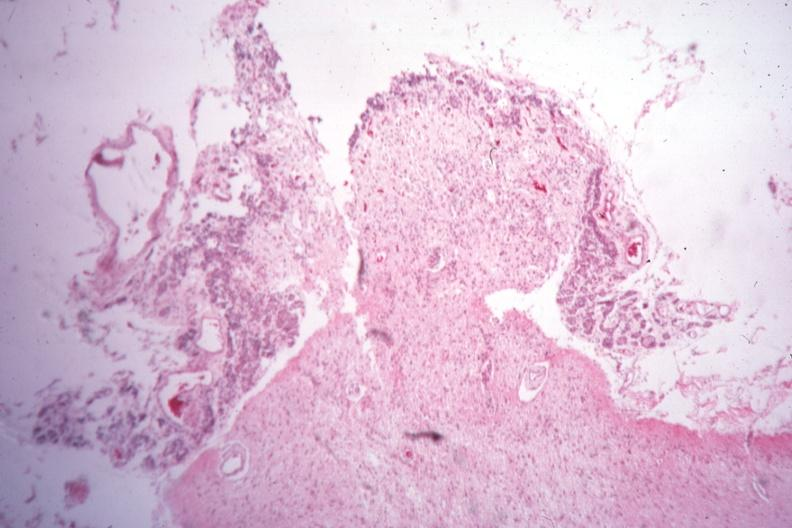what was section through pituitary stalk showing what remains sella of type i diabetes with pituitectomy for retinal lesions 9 years?
Answer the question using a single word or phrase. Empty case 